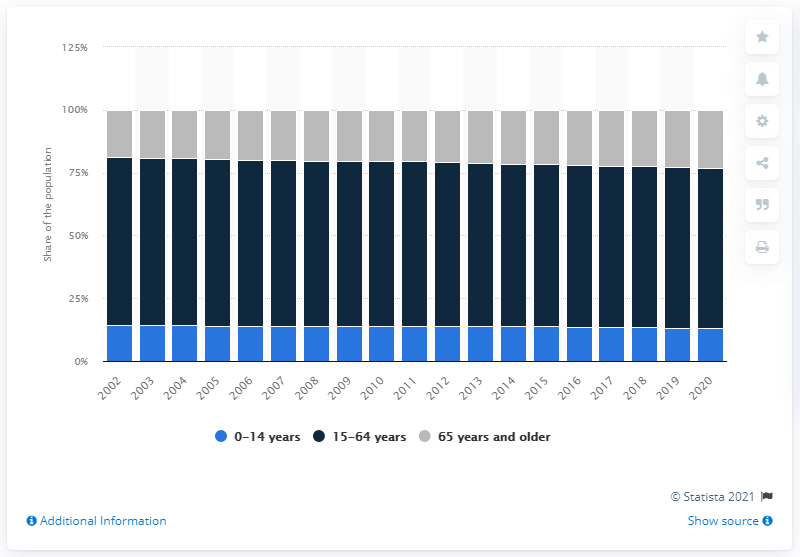Mention a couple of crucial points in this snapshot. In 2020, approximately 23.2% of Italians were over the age of 65. 